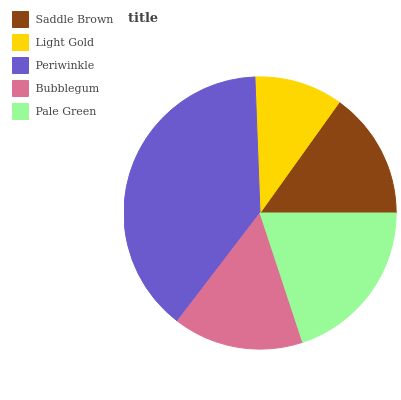Is Light Gold the minimum?
Answer yes or no. Yes. Is Periwinkle the maximum?
Answer yes or no. Yes. Is Periwinkle the minimum?
Answer yes or no. No. Is Light Gold the maximum?
Answer yes or no. No. Is Periwinkle greater than Light Gold?
Answer yes or no. Yes. Is Light Gold less than Periwinkle?
Answer yes or no. Yes. Is Light Gold greater than Periwinkle?
Answer yes or no. No. Is Periwinkle less than Light Gold?
Answer yes or no. No. Is Bubblegum the high median?
Answer yes or no. Yes. Is Bubblegum the low median?
Answer yes or no. Yes. Is Saddle Brown the high median?
Answer yes or no. No. Is Saddle Brown the low median?
Answer yes or no. No. 